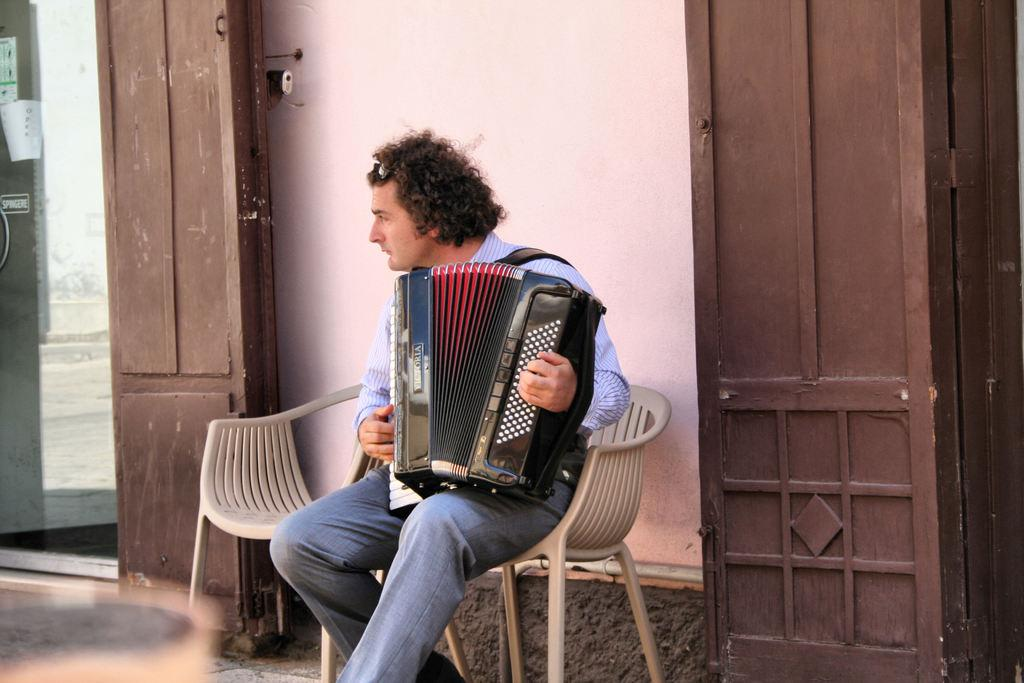Who is the person in the image? There is a man in the image. What is the man doing in the image? The man is sitting on a chair and playing a harmonium. What can be seen beneath the man's feet in the image? There is a floor in the image. What architectural features are present in the image? There is a door and a wall in the image. What is the size of the volleyball in the image? There is no volleyball present in the image. What type of tax is being discussed in the image? There is no discussion of tax in the image. 